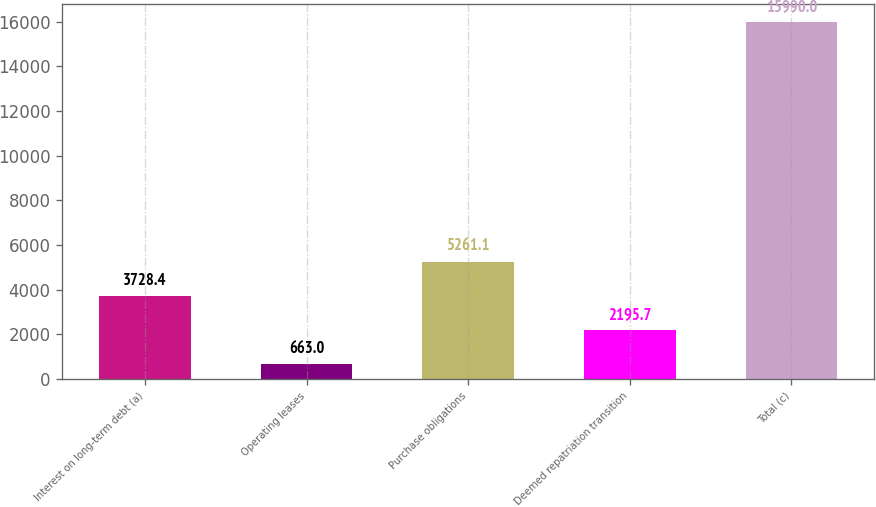<chart> <loc_0><loc_0><loc_500><loc_500><bar_chart><fcel>Interest on long-term debt (a)<fcel>Operating leases<fcel>Purchase obligations<fcel>Deemed repatriation transition<fcel>Total (c)<nl><fcel>3728.4<fcel>663<fcel>5261.1<fcel>2195.7<fcel>15990<nl></chart> 